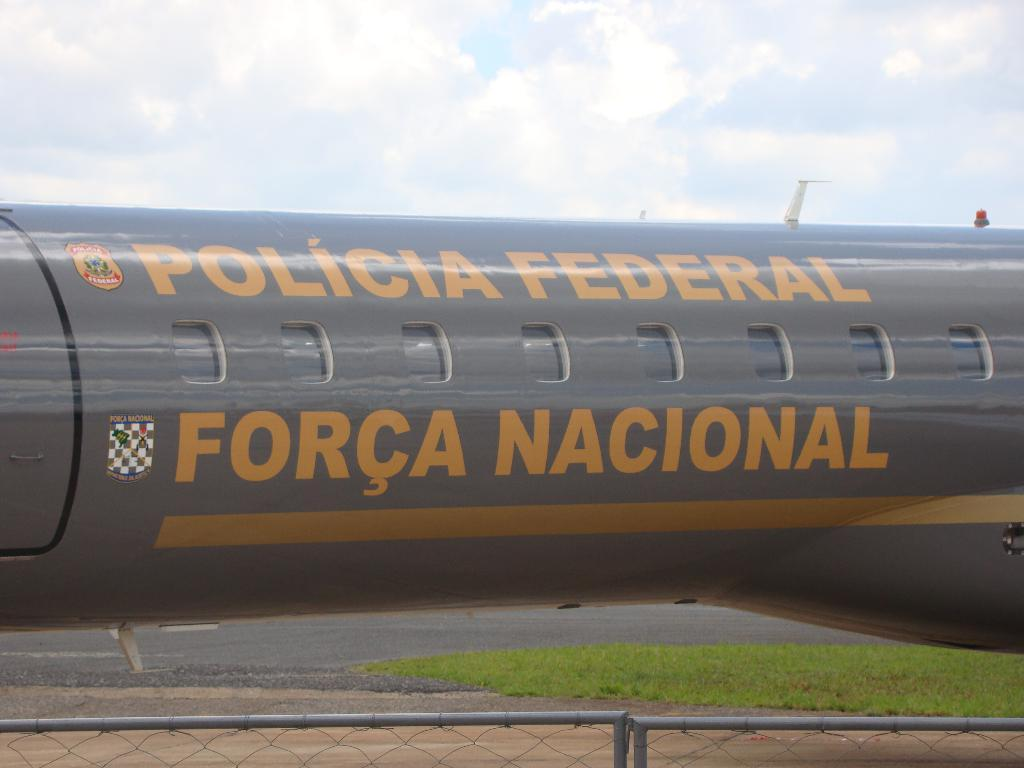What is the main subject of the picture? The main subject of the picture is an airplane. What can be inferred about the airplane from the image? The airplane belongs to the police. What is located in front of the airplane in the image? There is a fencing in front of the airplane. What type of bead is hanging from the airplane's chin in the image? There is no bead or chin present on the airplane in the image. How many hooks can be seen attached to the airplane in the image? There are no hooks visible on the airplane in the image. 